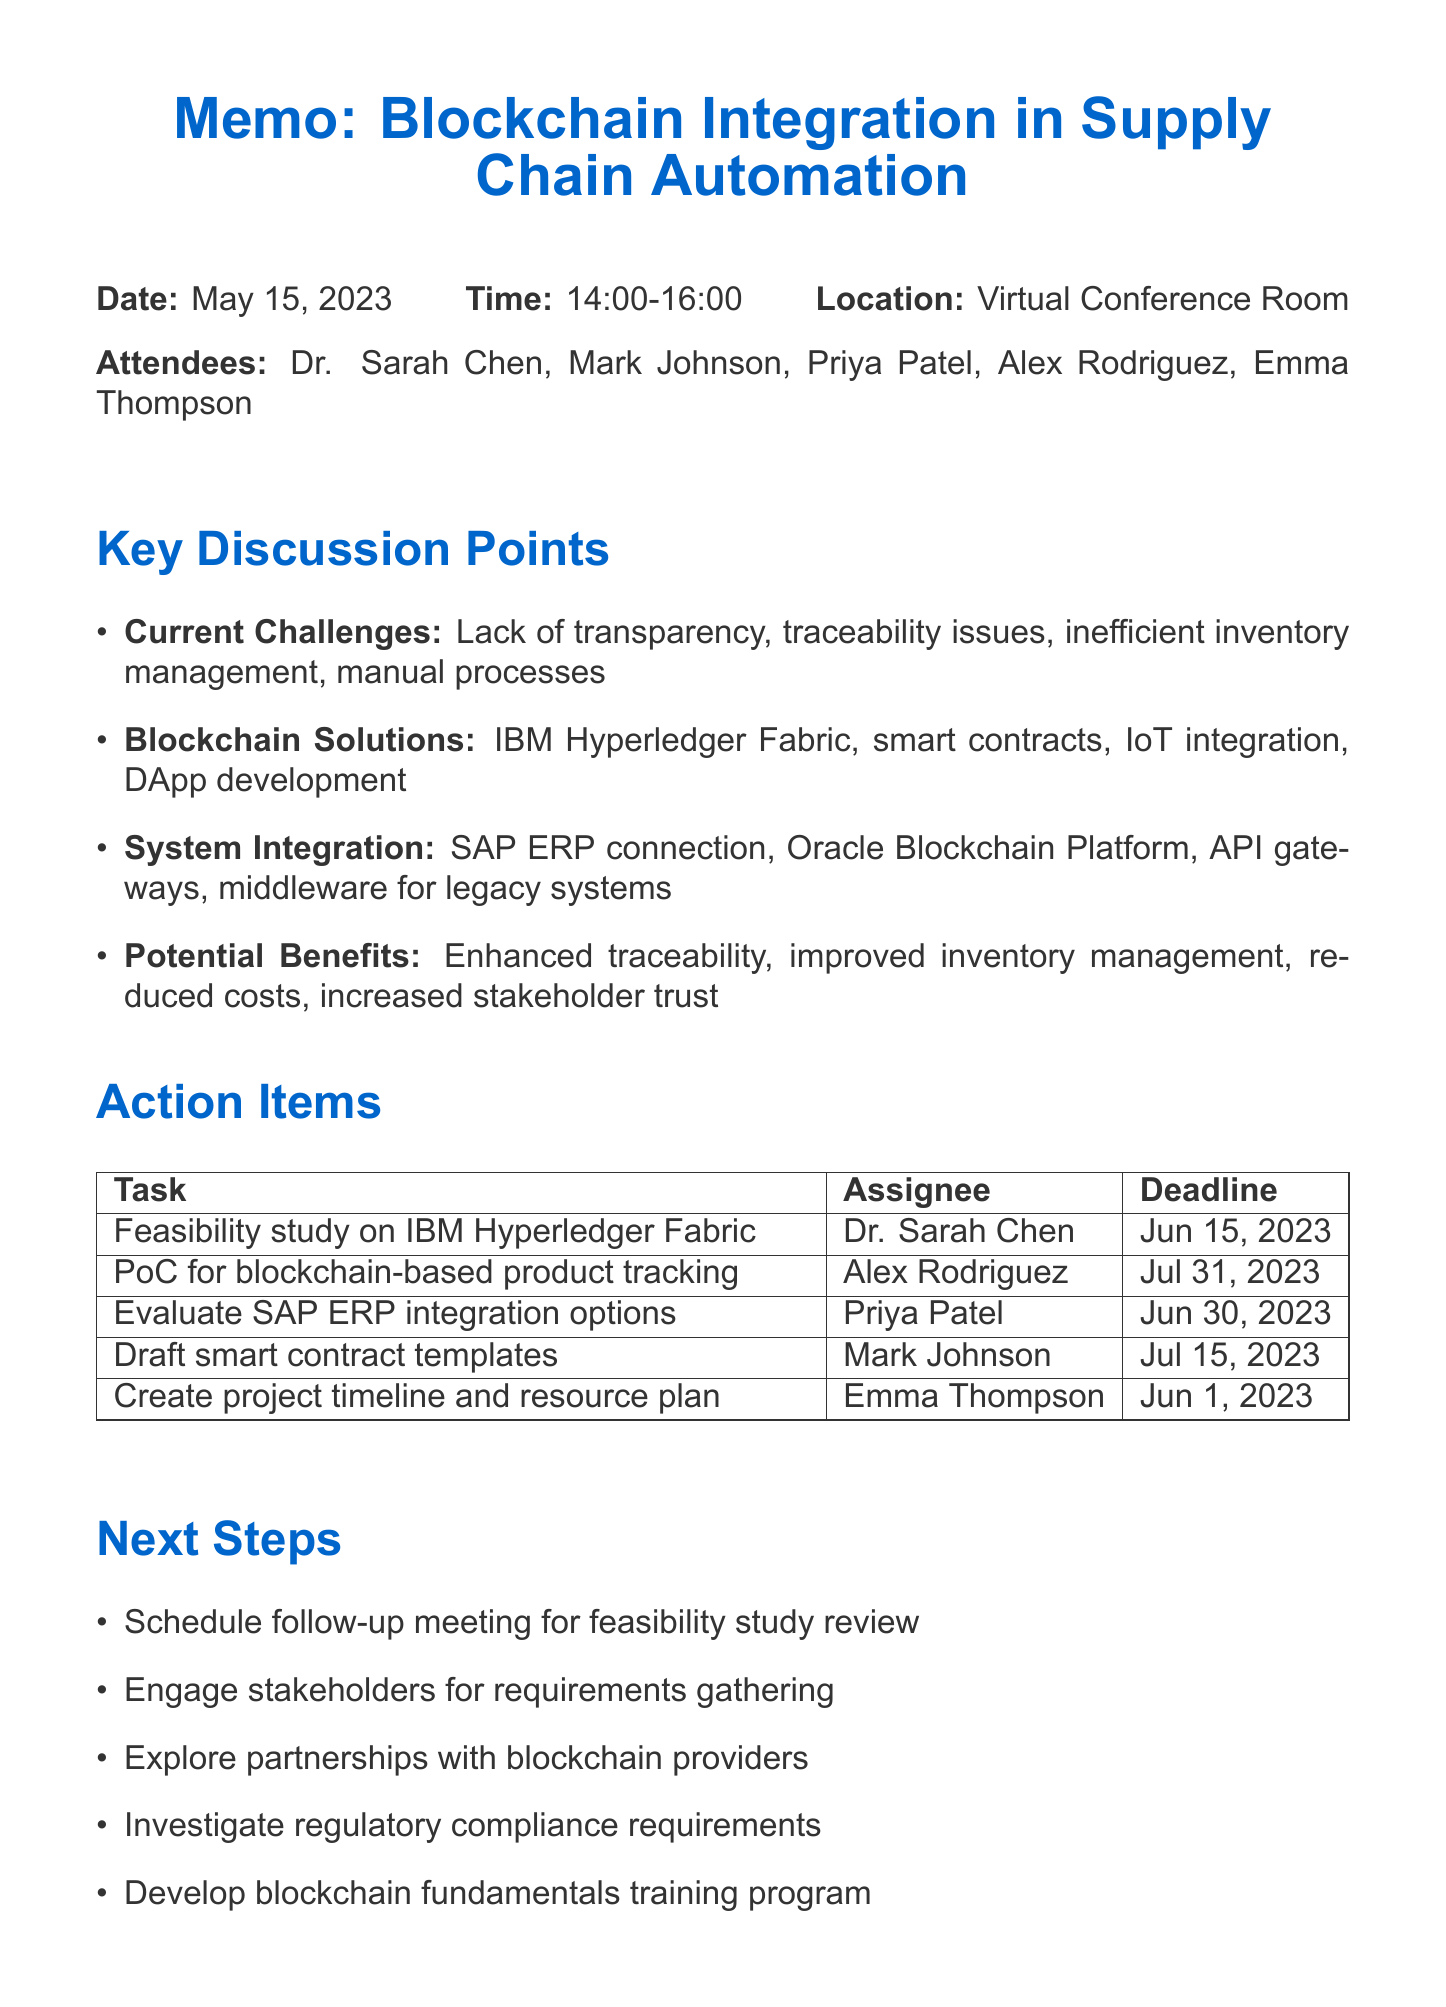What is the date of the meeting? The date of the meeting is listed in the document under meeting details.
Answer: May 15, 2023 Who is responsible for conducting the feasibility study? The action items section states the task along with the assignee for the feasibility study.
Answer: Dr. Sarah Chen What is the deadline for the proof-of-concept development? The action items clearly specify deadlines for each task, including this one.
Answer: July 31, 2023 What technology is proposed for enhancing traceability? This is mentioned under potential benefits and blockchain solutions in the discussion points.
Answer: IBM Hyperledger Fabric What is the first key decision regarding the blockchain network? The key decisions section lists various decisions made during the meeting; the first is specifically about the type of network.
Answer: Permissioned blockchain network When is the follow-up meeting to review results scheduled? While specific scheduling details may not be provided, the next steps indicate a follow-up meeting will occur after a certain event.
Answer: After the feasibility study review Who will draft the initial smart contract templates? The action items section assigns this task to a specific attendee.
Answer: Mark Johnson What is a potential benefit of implementing blockchain technology? This is mentioned among the benefits listed in the discussion points section.
Answer: Improved inventory management 